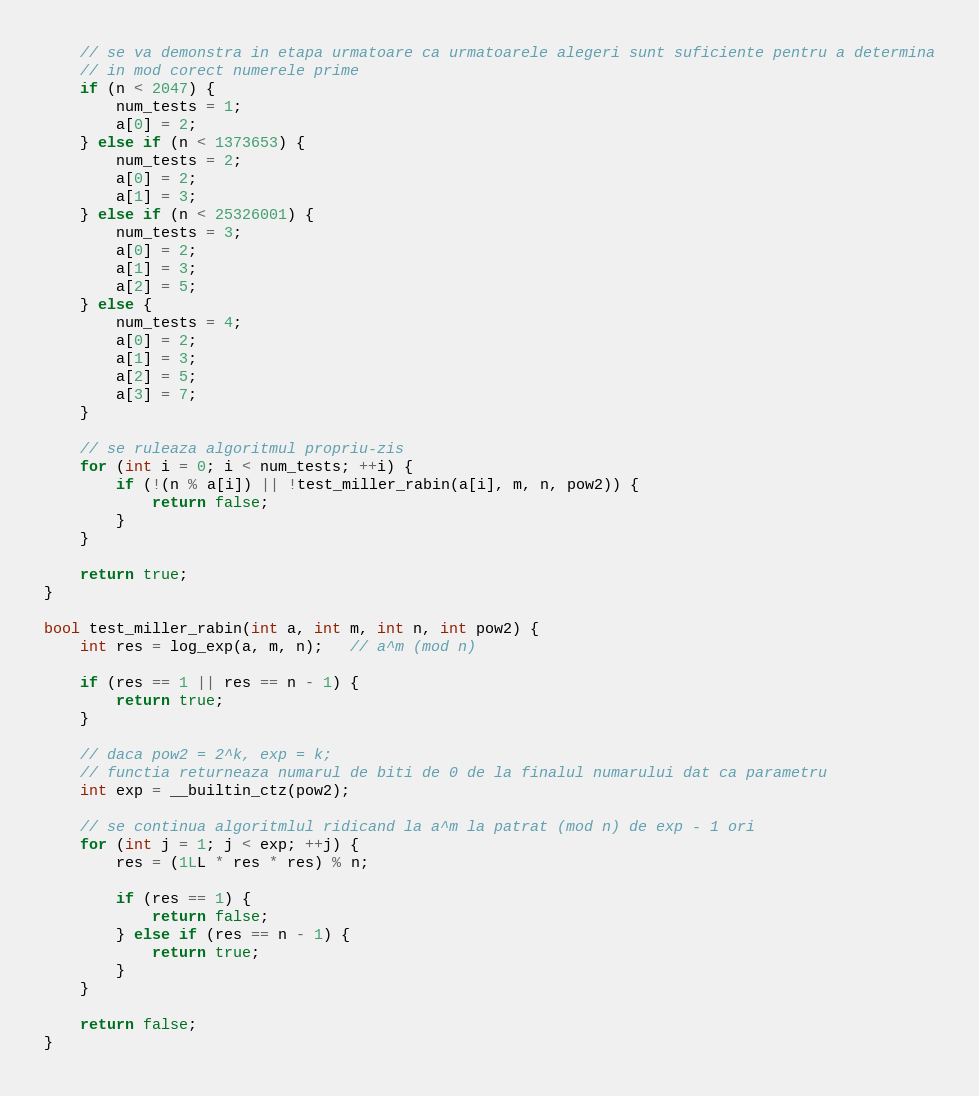Convert code to text. <code><loc_0><loc_0><loc_500><loc_500><_C++_>    // se va demonstra in etapa urmatoare ca urmatoarele alegeri sunt suficiente pentru a determina
    // in mod corect numerele prime
    if (n < 2047) {
        num_tests = 1;
        a[0] = 2;
    } else if (n < 1373653) {
        num_tests = 2;
        a[0] = 2;
        a[1] = 3;
    } else if (n < 25326001) {
        num_tests = 3;
        a[0] = 2;
        a[1] = 3;
        a[2] = 5;
    } else {
        num_tests = 4;
        a[0] = 2;
        a[1] = 3;
        a[2] = 5;
        a[3] = 7;
    }

    // se ruleaza algoritmul propriu-zis
    for (int i = 0; i < num_tests; ++i) {
        if (!(n % a[i]) || !test_miller_rabin(a[i], m, n, pow2)) {
            return false;
        }
    }

    return true;
}

bool test_miller_rabin(int a, int m, int n, int pow2) {
    int res = log_exp(a, m, n);   // a^m (mod n)

    if (res == 1 || res == n - 1) {
        return true;
    }

    // daca pow2 = 2^k, exp = k;
    // functia returneaza numarul de biti de 0 de la finalul numarului dat ca parametru
    int exp = __builtin_ctz(pow2);

    // se continua algoritmlul ridicand la a^m la patrat (mod n) de exp - 1 ori
    for (int j = 1; j < exp; ++j) {
        res = (1LL * res * res) % n;

        if (res == 1) {
            return false;
        } else if (res == n - 1) {
            return true;
        }
    }

    return false;
}</code> 